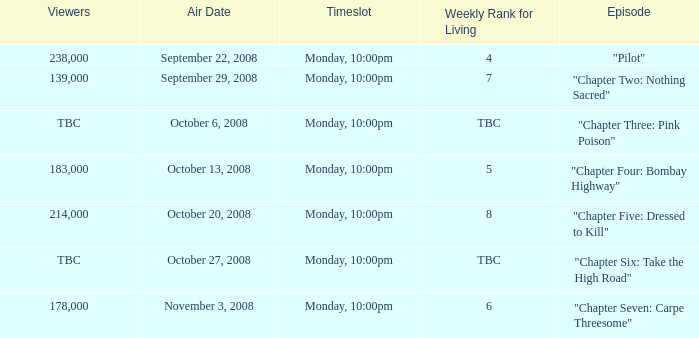What is the weekly rank for living when the air date is october 6, 2008? TBC. 